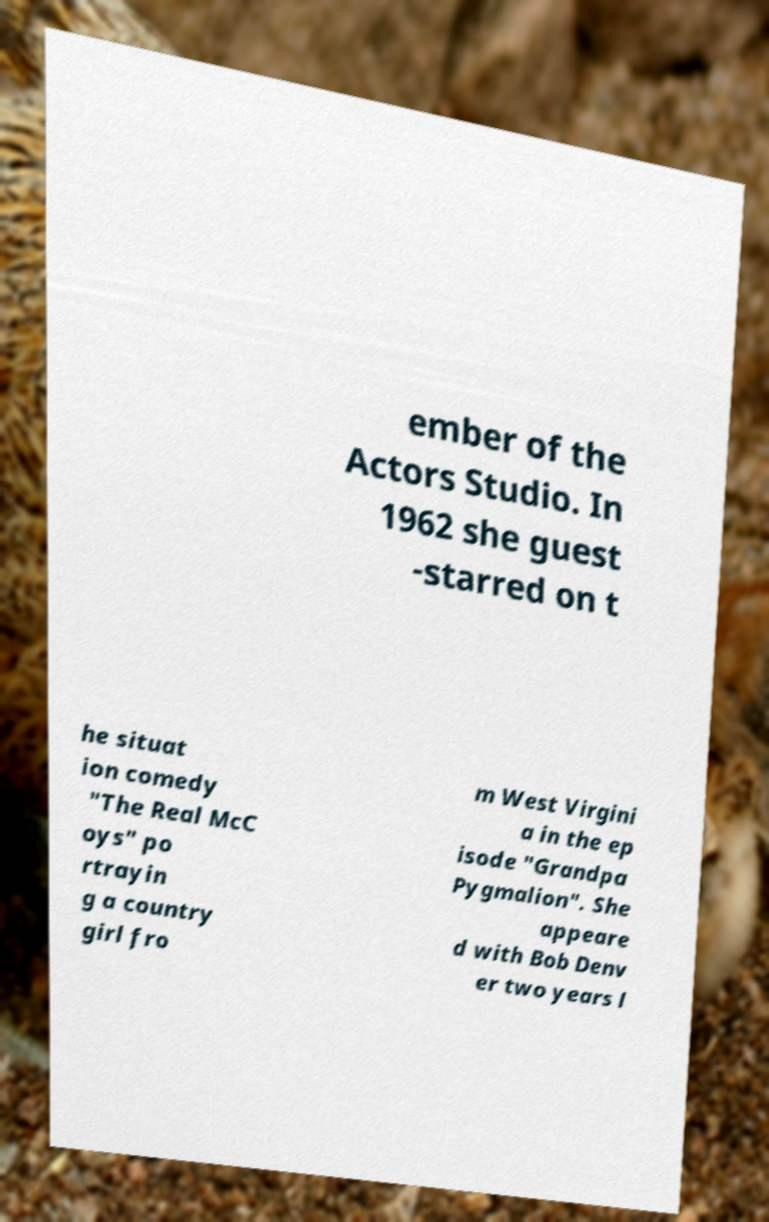What messages or text are displayed in this image? I need them in a readable, typed format. ember of the Actors Studio. In 1962 she guest -starred on t he situat ion comedy "The Real McC oys" po rtrayin g a country girl fro m West Virgini a in the ep isode "Grandpa Pygmalion". She appeare d with Bob Denv er two years l 